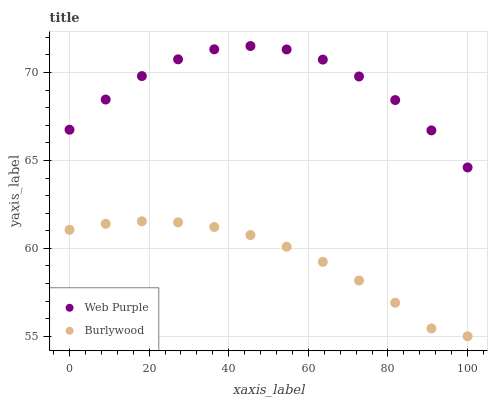Does Burlywood have the minimum area under the curve?
Answer yes or no. Yes. Does Web Purple have the maximum area under the curve?
Answer yes or no. Yes. Does Web Purple have the minimum area under the curve?
Answer yes or no. No. Is Burlywood the smoothest?
Answer yes or no. Yes. Is Web Purple the roughest?
Answer yes or no. Yes. Is Web Purple the smoothest?
Answer yes or no. No. Does Burlywood have the lowest value?
Answer yes or no. Yes. Does Web Purple have the lowest value?
Answer yes or no. No. Does Web Purple have the highest value?
Answer yes or no. Yes. Is Burlywood less than Web Purple?
Answer yes or no. Yes. Is Web Purple greater than Burlywood?
Answer yes or no. Yes. Does Burlywood intersect Web Purple?
Answer yes or no. No. 